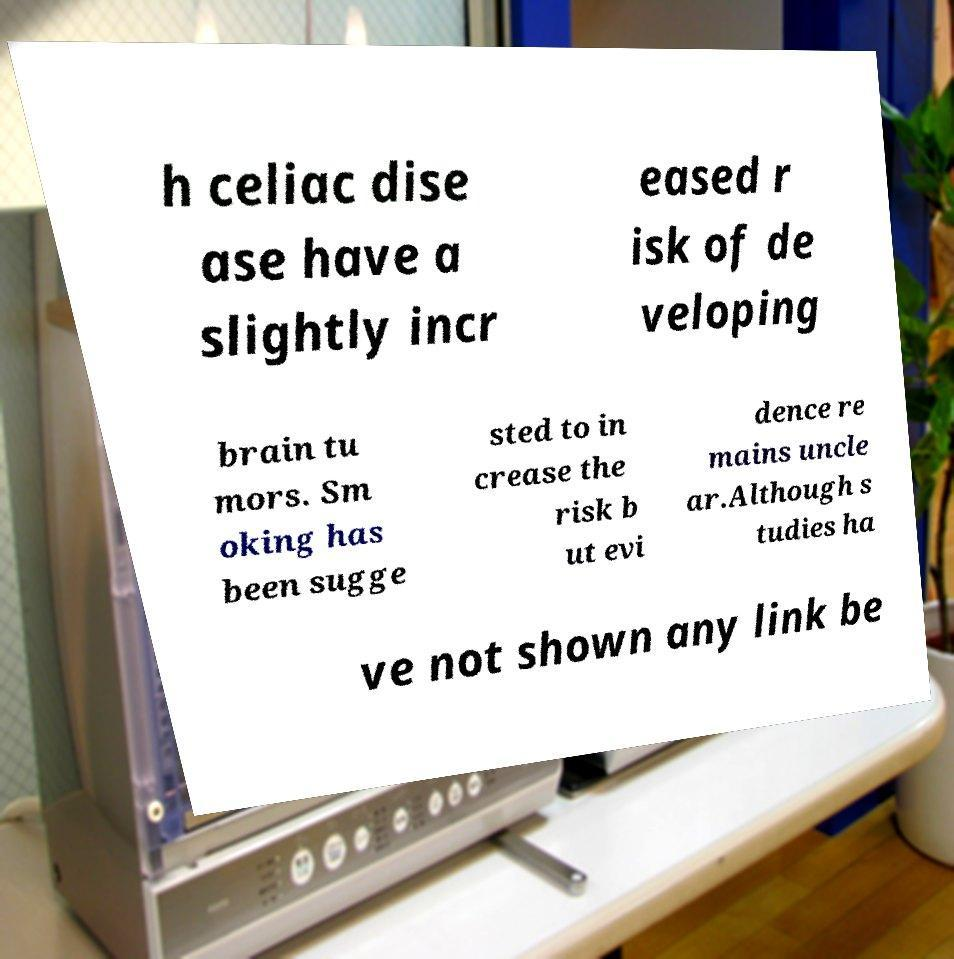There's text embedded in this image that I need extracted. Can you transcribe it verbatim? h celiac dise ase have a slightly incr eased r isk of de veloping brain tu mors. Sm oking has been sugge sted to in crease the risk b ut evi dence re mains uncle ar.Although s tudies ha ve not shown any link be 